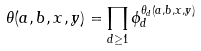Convert formula to latex. <formula><loc_0><loc_0><loc_500><loc_500>\theta ( a , b , x , y ) = \prod _ { d \geq 1 } \phi _ { d } ^ { \theta _ { d } ( a , b , x , y ) }</formula> 